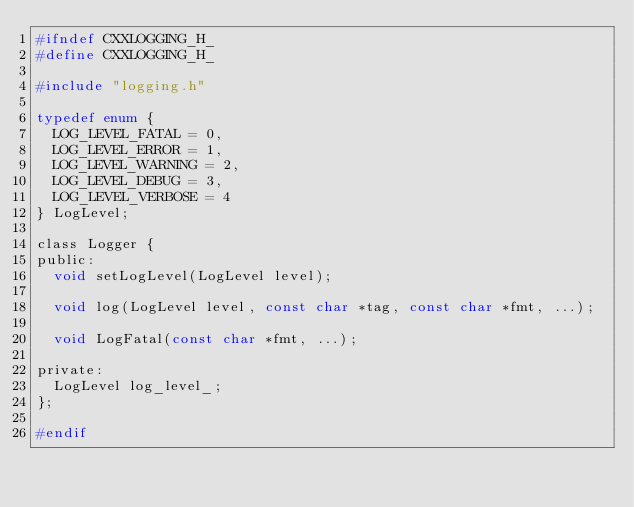<code> <loc_0><loc_0><loc_500><loc_500><_C_>#ifndef CXXLOGGING_H_
#define CXXLOGGING_H_

#include "logging.h"

typedef enum {
  LOG_LEVEL_FATAL = 0,
  LOG_LEVEL_ERROR = 1,
  LOG_LEVEL_WARNING = 2,
  LOG_LEVEL_DEBUG = 3,
  LOG_LEVEL_VERBOSE = 4
} LogLevel;

class Logger {
public:
  void setLogLevel(LogLevel level);

  void log(LogLevel level, const char *tag, const char *fmt, ...);

  void LogFatal(const char *fmt, ...);

private:
  LogLevel log_level_;
};

#endif
</code> 